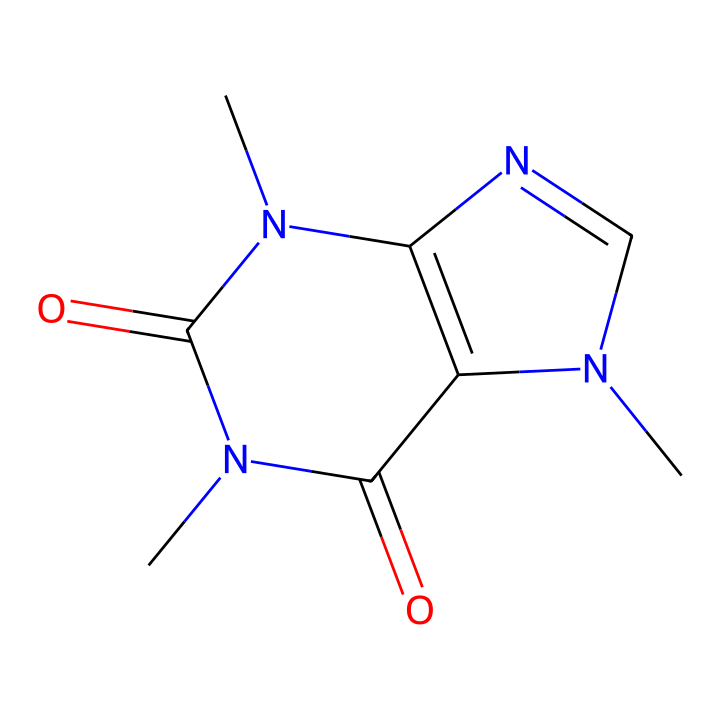What is the molecular formula of this compound? The SMILES representation indicates the presence of several carbon (C), nitrogen (N), and oxygen (O) atoms. By identifying and counting them in the structure, we find there are 8 carbons, 10 hydrogens, 4 nitrogens, and 2 oxygens. Hence, the molecular formula derived from the count is C8H10N4O2.
Answer: C8H10N4O2 How many nitrogen atoms are present in the structure? By analyzing the SMILES notation, we can locate the nitrogen atoms. There are four instances of 'N' in the representation, indicating the presence of four nitrogen atoms in the molecule.
Answer: 4 What type of chemical compound is caffeine? Caffeine is recognized as an alkaloid due to the presence of nitrogen atoms within its structure, which are characteristic of such compounds. This classification is derived from its biologically active and nitrogenous nature.
Answer: alkaloid Which functional groups are present in caffeine? Looking carefully at the SMILES structure, we can identify the carbonyl (C=O) and amine (N) groups. The presence of carbonyl groups is noted where double-bonded oxygens are attached directly to carbon atoms, along with nitrogen atoms showing the presence of amines.
Answer: amine, carbonyl What is the total number of rings in the structure of caffeine? In the SMILES, the segments indicate the presence of cyclic structures or rings. There are two rings in total, further corroborated by the connections and arrangements of the atoms in the representation.
Answer: 2 How does the presence of multiple nitrogen atoms affect caffeine's properties? The multiple nitrogen atoms contribute to the basicity of caffeine, which also enhances its psychoactive effects, characteristic of many nitrogen-containing compounds such as stimulants. This typical structural feature leads to pronounced biological activity in caffeine, influencing its role in behavior and metabolism.
Answer: basicity 